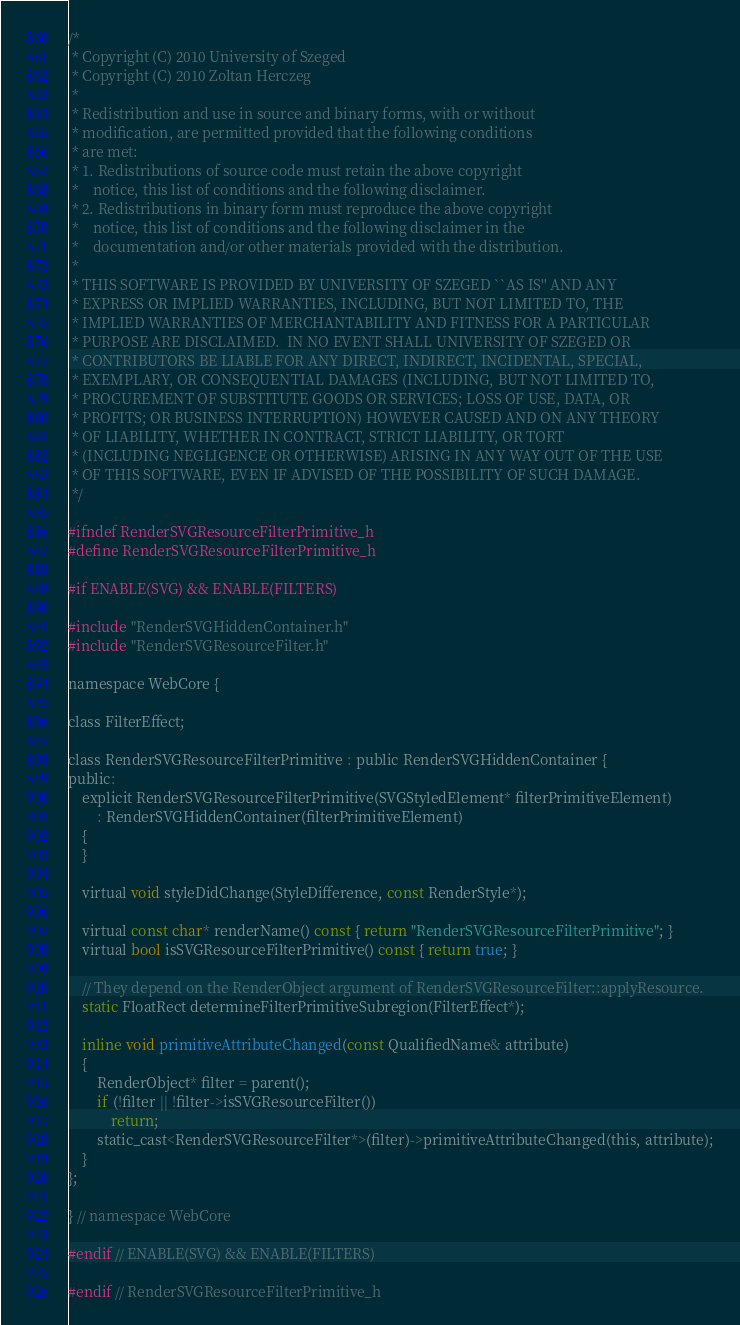Convert code to text. <code><loc_0><loc_0><loc_500><loc_500><_C_>/*
 * Copyright (C) 2010 University of Szeged
 * Copyright (C) 2010 Zoltan Herczeg
 *
 * Redistribution and use in source and binary forms, with or without
 * modification, are permitted provided that the following conditions
 * are met:
 * 1. Redistributions of source code must retain the above copyright
 *    notice, this list of conditions and the following disclaimer.
 * 2. Redistributions in binary form must reproduce the above copyright
 *    notice, this list of conditions and the following disclaimer in the
 *    documentation and/or other materials provided with the distribution.
 *
 * THIS SOFTWARE IS PROVIDED BY UNIVERSITY OF SZEGED ``AS IS'' AND ANY
 * EXPRESS OR IMPLIED WARRANTIES, INCLUDING, BUT NOT LIMITED TO, THE
 * IMPLIED WARRANTIES OF MERCHANTABILITY AND FITNESS FOR A PARTICULAR
 * PURPOSE ARE DISCLAIMED.  IN NO EVENT SHALL UNIVERSITY OF SZEGED OR
 * CONTRIBUTORS BE LIABLE FOR ANY DIRECT, INDIRECT, INCIDENTAL, SPECIAL,
 * EXEMPLARY, OR CONSEQUENTIAL DAMAGES (INCLUDING, BUT NOT LIMITED TO,
 * PROCUREMENT OF SUBSTITUTE GOODS OR SERVICES; LOSS OF USE, DATA, OR
 * PROFITS; OR BUSINESS INTERRUPTION) HOWEVER CAUSED AND ON ANY THEORY
 * OF LIABILITY, WHETHER IN CONTRACT, STRICT LIABILITY, OR TORT
 * (INCLUDING NEGLIGENCE OR OTHERWISE) ARISING IN ANY WAY OUT OF THE USE
 * OF THIS SOFTWARE, EVEN IF ADVISED OF THE POSSIBILITY OF SUCH DAMAGE.
 */

#ifndef RenderSVGResourceFilterPrimitive_h
#define RenderSVGResourceFilterPrimitive_h

#if ENABLE(SVG) && ENABLE(FILTERS)

#include "RenderSVGHiddenContainer.h"
#include "RenderSVGResourceFilter.h"

namespace WebCore {

class FilterEffect;

class RenderSVGResourceFilterPrimitive : public RenderSVGHiddenContainer {
public:
    explicit RenderSVGResourceFilterPrimitive(SVGStyledElement* filterPrimitiveElement)
        : RenderSVGHiddenContainer(filterPrimitiveElement)
    {
    }

    virtual void styleDidChange(StyleDifference, const RenderStyle*);

    virtual const char* renderName() const { return "RenderSVGResourceFilterPrimitive"; }
    virtual bool isSVGResourceFilterPrimitive() const { return true; }

    // They depend on the RenderObject argument of RenderSVGResourceFilter::applyResource.
    static FloatRect determineFilterPrimitiveSubregion(FilterEffect*);

    inline void primitiveAttributeChanged(const QualifiedName& attribute)
    {
        RenderObject* filter = parent();
        if (!filter || !filter->isSVGResourceFilter())
            return;
        static_cast<RenderSVGResourceFilter*>(filter)->primitiveAttributeChanged(this, attribute);
    }
};

} // namespace WebCore

#endif // ENABLE(SVG) && ENABLE(FILTERS)

#endif // RenderSVGResourceFilterPrimitive_h
</code> 